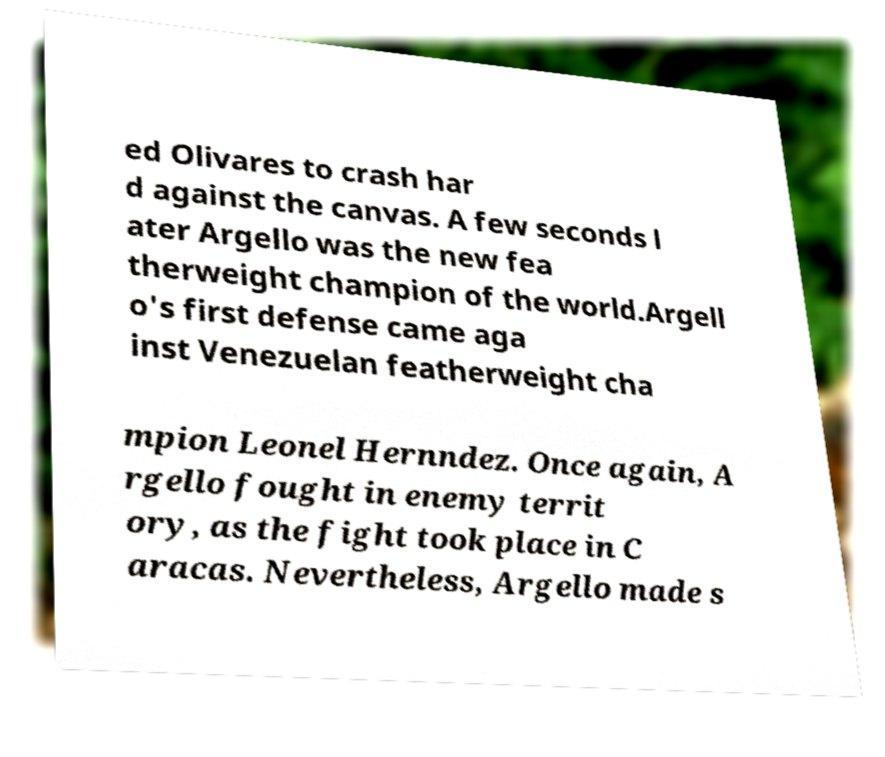Could you extract and type out the text from this image? ed Olivares to crash har d against the canvas. A few seconds l ater Argello was the new fea therweight champion of the world.Argell o's first defense came aga inst Venezuelan featherweight cha mpion Leonel Hernndez. Once again, A rgello fought in enemy territ ory, as the fight took place in C aracas. Nevertheless, Argello made s 